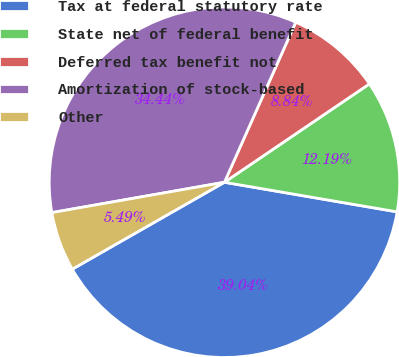<chart> <loc_0><loc_0><loc_500><loc_500><pie_chart><fcel>Tax at federal statutory rate<fcel>State net of federal benefit<fcel>Deferred tax benefit not<fcel>Amortization of stock-based<fcel>Other<nl><fcel>39.04%<fcel>12.19%<fcel>8.84%<fcel>34.44%<fcel>5.49%<nl></chart> 